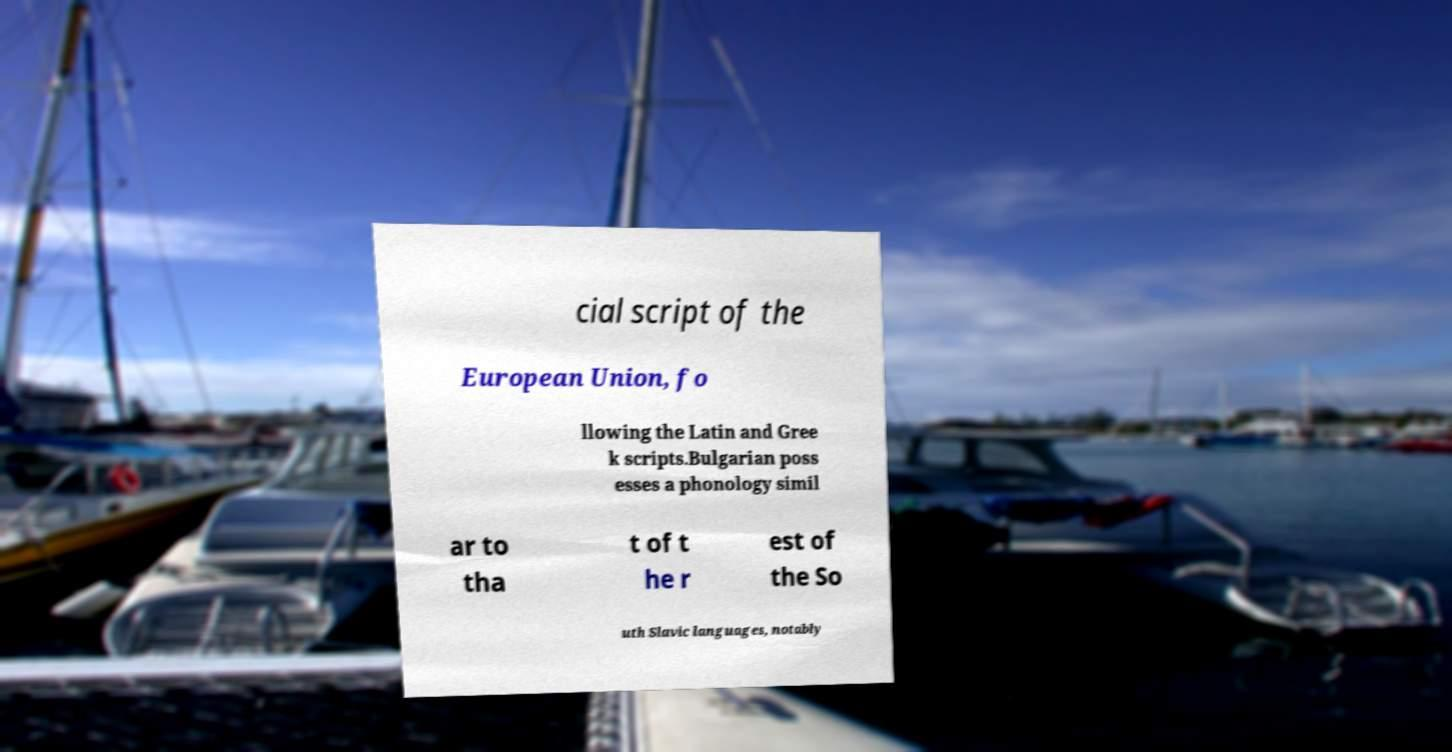Could you extract and type out the text from this image? cial script of the European Union, fo llowing the Latin and Gree k scripts.Bulgarian poss esses a phonology simil ar to tha t of t he r est of the So uth Slavic languages, notably 